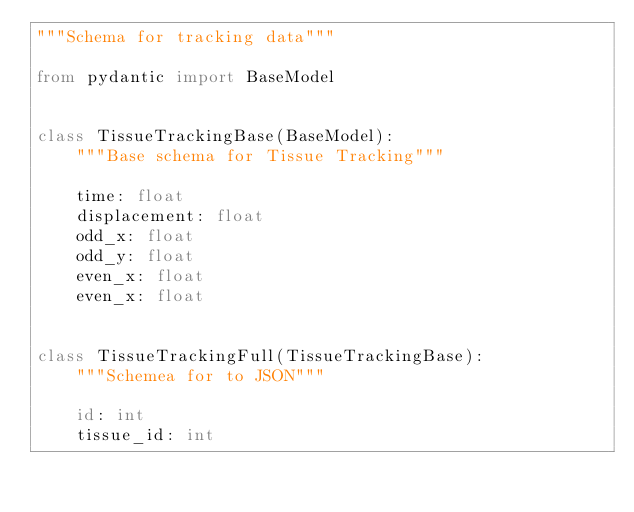Convert code to text. <code><loc_0><loc_0><loc_500><loc_500><_Python_>"""Schema for tracking data"""

from pydantic import BaseModel


class TissueTrackingBase(BaseModel):
    """Base schema for Tissue Tracking"""

    time: float
    displacement: float
    odd_x: float
    odd_y: float
    even_x: float
    even_x: float


class TissueTrackingFull(TissueTrackingBase):
    """Schemea for to JSON"""

    id: int
    tissue_id: int
</code> 